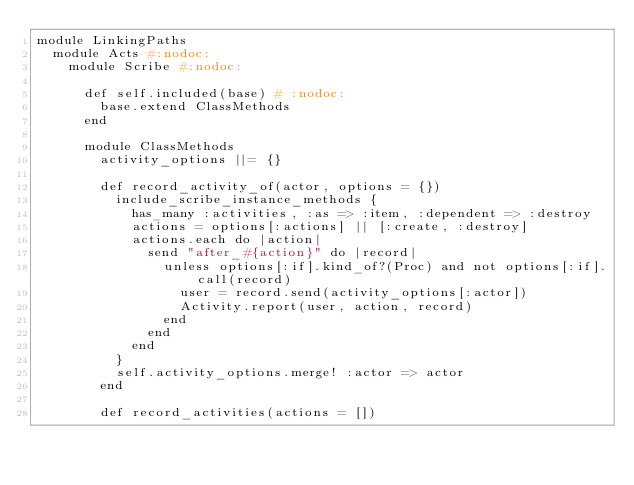Convert code to text. <code><loc_0><loc_0><loc_500><loc_500><_Ruby_>module LinkingPaths
  module Acts #:nodoc:
    module Scribe #:nodoc:

      def self.included(base) # :nodoc:
        base.extend ClassMethods
      end

      module ClassMethods
        activity_options ||= {}

        def record_activity_of(actor, options = {})
          include_scribe_instance_methods {
            has_many :activities, :as => :item, :dependent => :destroy
            actions = options[:actions] || [:create, :destroy]
            actions.each do |action|
              send "after_#{action}" do |record|
                unless options[:if].kind_of?(Proc) and not options[:if].call(record)
                  user = record.send(activity_options[:actor])
                  Activity.report(user, action, record)
                end
              end
            end
          }
          self.activity_options.merge! :actor => actor
        end

        def record_activities(actions = [])</code> 